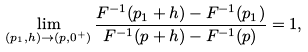<formula> <loc_0><loc_0><loc_500><loc_500>\lim _ { ( p _ { 1 } , h ) \to ( p , 0 ^ { + } ) } \frac { F ^ { - 1 } ( p _ { 1 } + h ) - F ^ { - 1 } ( p _ { 1 } ) } { F ^ { - 1 } ( p + h ) - F ^ { - 1 } ( p ) } = 1 ,</formula> 